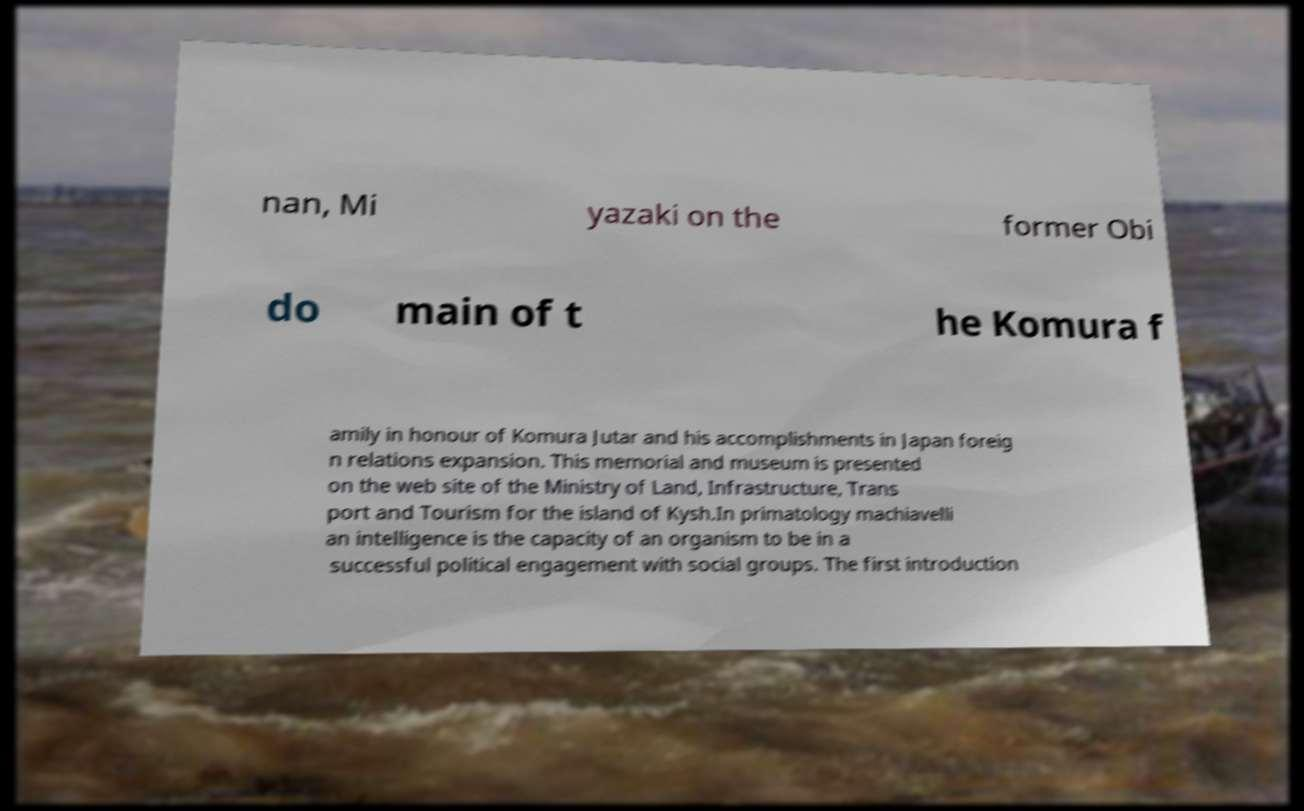Can you read and provide the text displayed in the image?This photo seems to have some interesting text. Can you extract and type it out for me? nan, Mi yazaki on the former Obi do main of t he Komura f amily in honour of Komura Jutar and his accomplishments in Japan foreig n relations expansion. This memorial and museum is presented on the web site of the Ministry of Land, Infrastructure, Trans port and Tourism for the island of Kysh.In primatology machiavelli an intelligence is the capacity of an organism to be in a successful political engagement with social groups. The first introduction 